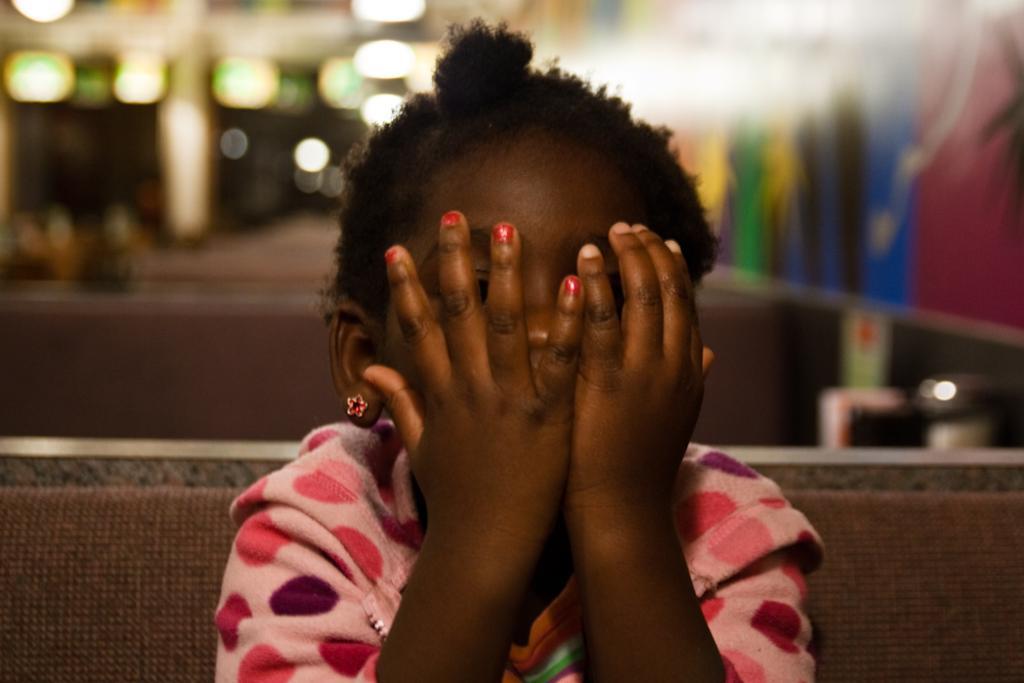In one or two sentences, can you explain what this image depicts? In this image there is a girl covering her face with her hands is sitting on the bench. 